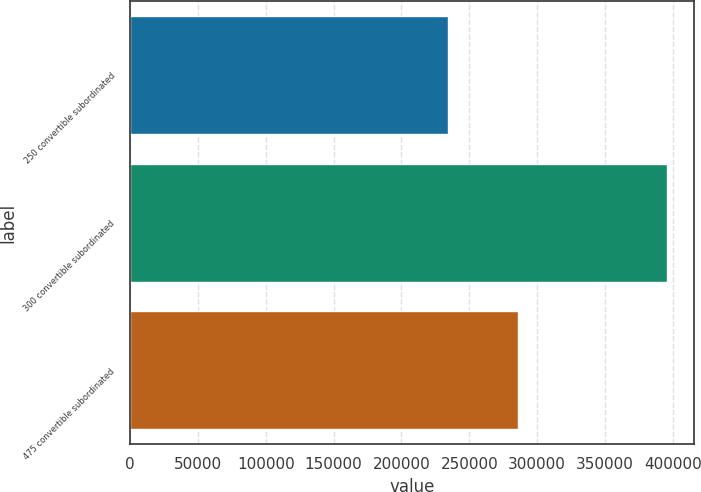<chart> <loc_0><loc_0><loc_500><loc_500><bar_chart><fcel>250 convertible subordinated<fcel>300 convertible subordinated<fcel>475 convertible subordinated<nl><fcel>234185<fcel>395986<fcel>286166<nl></chart> 